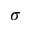<formula> <loc_0><loc_0><loc_500><loc_500>\sigma</formula> 